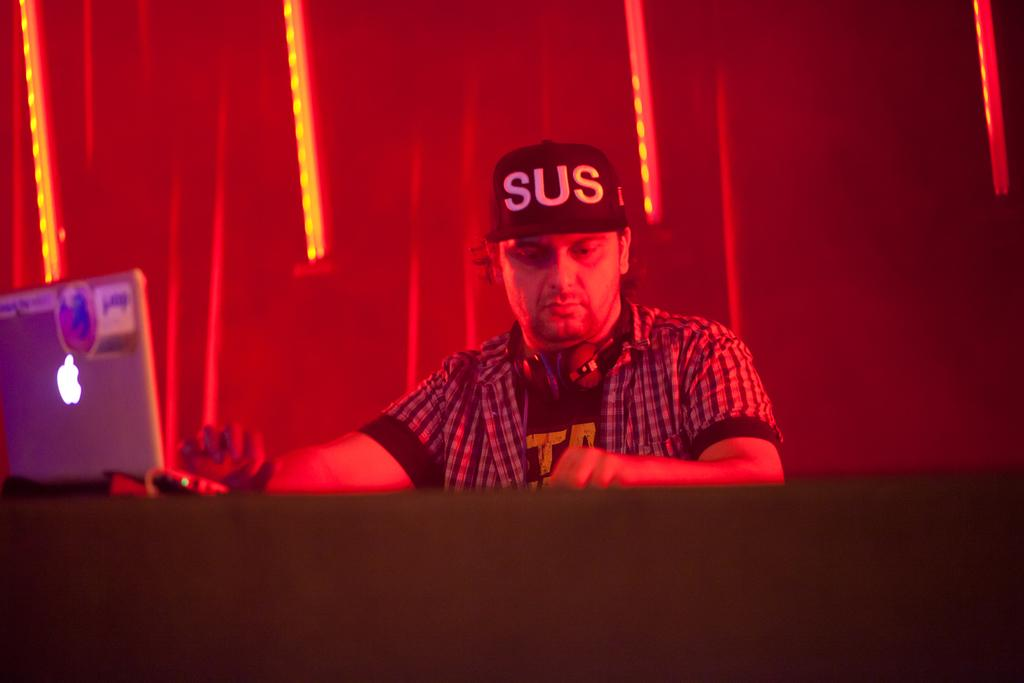Who is present in the image? There is a person in the image. What is the person wearing on their head? The person is wearing a cap. What is the person using to listen to audio? The person is wearing headphones. What device is in front of the person? There is a laptop in front of the person. What can be seen in the background of the image? There is a wall with lights in the background of the image. How many brothers does the person in the image have? There is no information about the person's siblings in the image, so it cannot be determined. 